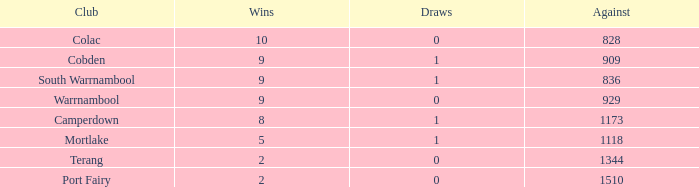Calculate the average draws when losses are more than 8 and against values are less than 1344. None. 